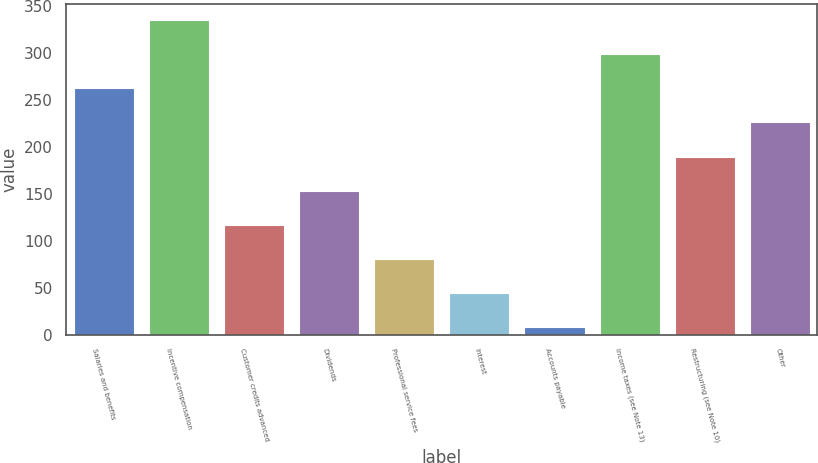<chart> <loc_0><loc_0><loc_500><loc_500><bar_chart><fcel>Salaries and benefits<fcel>Incentive compensation<fcel>Customer credits advanced<fcel>Dividends<fcel>Professional service fees<fcel>Interest<fcel>Accounts payable<fcel>Income taxes (see Note 13)<fcel>Restructuring (see Note 10)<fcel>Other<nl><fcel>262.34<fcel>334.98<fcel>117.06<fcel>153.38<fcel>80.74<fcel>44.42<fcel>8.1<fcel>298.66<fcel>189.7<fcel>226.02<nl></chart> 